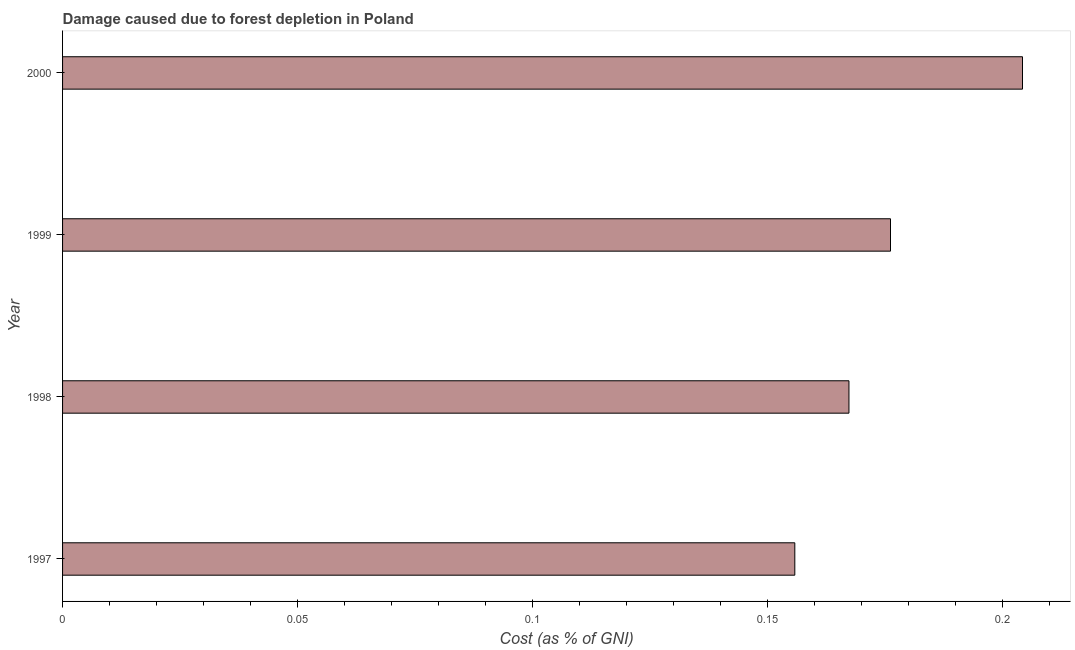What is the title of the graph?
Provide a succinct answer. Damage caused due to forest depletion in Poland. What is the label or title of the X-axis?
Make the answer very short. Cost (as % of GNI). What is the damage caused due to forest depletion in 1997?
Provide a succinct answer. 0.16. Across all years, what is the maximum damage caused due to forest depletion?
Ensure brevity in your answer.  0.2. Across all years, what is the minimum damage caused due to forest depletion?
Offer a terse response. 0.16. In which year was the damage caused due to forest depletion maximum?
Your response must be concise. 2000. In which year was the damage caused due to forest depletion minimum?
Give a very brief answer. 1997. What is the sum of the damage caused due to forest depletion?
Your answer should be compact. 0.7. What is the difference between the damage caused due to forest depletion in 1997 and 1998?
Keep it short and to the point. -0.01. What is the average damage caused due to forest depletion per year?
Keep it short and to the point. 0.18. What is the median damage caused due to forest depletion?
Give a very brief answer. 0.17. In how many years, is the damage caused due to forest depletion greater than 0.14 %?
Provide a short and direct response. 4. Do a majority of the years between 2000 and 1997 (inclusive) have damage caused due to forest depletion greater than 0.08 %?
Provide a short and direct response. Yes. What is the ratio of the damage caused due to forest depletion in 1999 to that in 2000?
Offer a very short reply. 0.86. Is the difference between the damage caused due to forest depletion in 1997 and 1998 greater than the difference between any two years?
Make the answer very short. No. What is the difference between the highest and the second highest damage caused due to forest depletion?
Give a very brief answer. 0.03. What is the difference between the highest and the lowest damage caused due to forest depletion?
Provide a short and direct response. 0.05. Are all the bars in the graph horizontal?
Give a very brief answer. Yes. How many years are there in the graph?
Ensure brevity in your answer.  4. What is the Cost (as % of GNI) of 1997?
Offer a terse response. 0.16. What is the Cost (as % of GNI) of 1998?
Make the answer very short. 0.17. What is the Cost (as % of GNI) of 1999?
Offer a very short reply. 0.18. What is the Cost (as % of GNI) of 2000?
Provide a short and direct response. 0.2. What is the difference between the Cost (as % of GNI) in 1997 and 1998?
Give a very brief answer. -0.01. What is the difference between the Cost (as % of GNI) in 1997 and 1999?
Make the answer very short. -0.02. What is the difference between the Cost (as % of GNI) in 1997 and 2000?
Provide a short and direct response. -0.05. What is the difference between the Cost (as % of GNI) in 1998 and 1999?
Ensure brevity in your answer.  -0.01. What is the difference between the Cost (as % of GNI) in 1998 and 2000?
Provide a short and direct response. -0.04. What is the difference between the Cost (as % of GNI) in 1999 and 2000?
Give a very brief answer. -0.03. What is the ratio of the Cost (as % of GNI) in 1997 to that in 1999?
Ensure brevity in your answer.  0.88. What is the ratio of the Cost (as % of GNI) in 1997 to that in 2000?
Your answer should be very brief. 0.76. What is the ratio of the Cost (as % of GNI) in 1998 to that in 2000?
Keep it short and to the point. 0.82. What is the ratio of the Cost (as % of GNI) in 1999 to that in 2000?
Offer a terse response. 0.86. 